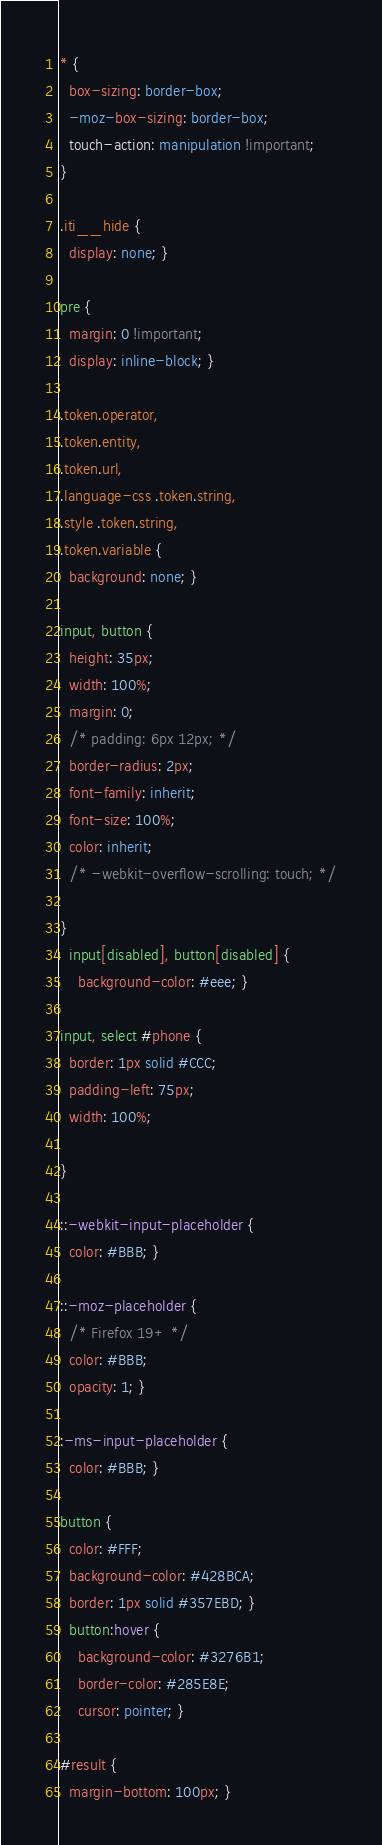<code> <loc_0><loc_0><loc_500><loc_500><_CSS_>* {
  box-sizing: border-box;
  -moz-box-sizing: border-box; 
  touch-action: manipulation !important;
}

.iti__hide {
  display: none; }  

pre {
  margin: 0 !important;
  display: inline-block; }

.token.operator,
.token.entity,
.token.url,
.language-css .token.string,
.style .token.string,
.token.variable {
  background: none; }

input, button {
  height: 35px;
  width: 100%;
  margin: 0;
  /* padding: 6px 12px; */
  border-radius: 2px;
  font-family: inherit;
  font-size: 100%;
  color: inherit; 
  /* -webkit-overflow-scrolling: touch; */
  
}
  input[disabled], button[disabled] {
    background-color: #eee; }

input, select #phone {
  border: 1px solid #CCC;
  padding-left: 75px;
  width: 100%; 
 
}

::-webkit-input-placeholder {
  color: #BBB; }

::-moz-placeholder {
  /* Firefox 19+ */
  color: #BBB;
  opacity: 1; }

:-ms-input-placeholder {
  color: #BBB; }

button {
  color: #FFF;
  background-color: #428BCA;
  border: 1px solid #357EBD; }
  button:hover {
    background-color: #3276B1;
    border-color: #285E8E;
    cursor: pointer; }

#result {
  margin-bottom: 100px; }</code> 